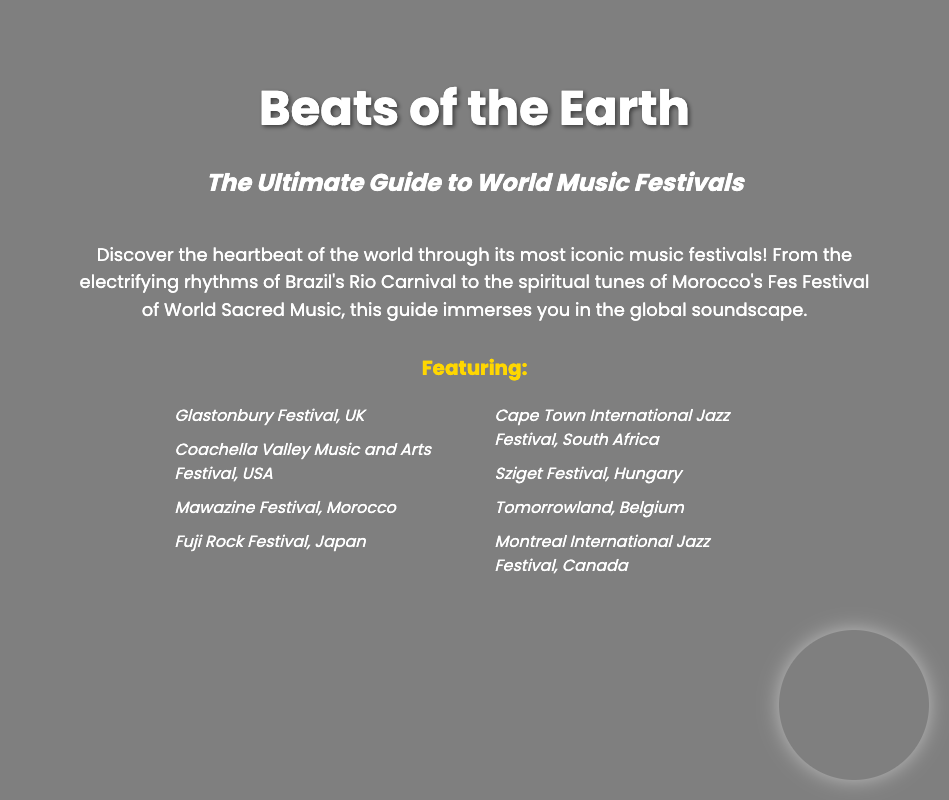What is the title of the book? The title of the book is prominently displayed at the top of the cover.
Answer: Beats of the Earth Who is the author? The author's name is located at the bottom of the cover in the footer section.
Answer: DJ Global Groove What is the subtitle of the book? The subtitle provides additional context about the book's content and is found beneath the title.
Answer: The Ultimate Guide to World Music Festivals How many music festivals are featured in the list? The number of festivals can be counted from the unordered list visible on the cover.
Answer: Eight Which festival is located in Belgium? The specific festival's name can be found in the list of featured festivals on the cover.
Answer: Tomorrowland What type of music events does the book focus on? The book is centered around a specific type of cultural gathering, which is inferred from the title and subtitle.
Answer: Music festivals What is included in the book aside from festival names? The description hints at additional content beyond just lists, referring to various cultural aspects.
Answer: Global soundscape Where does the Rio Carnival take place? The location of this iconic festival is mentioned in the description reflecting its cultural significance.
Answer: Brazil 